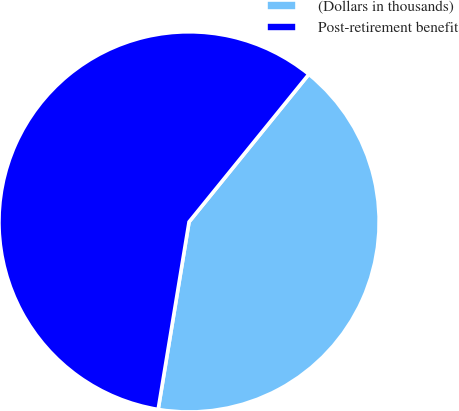<chart> <loc_0><loc_0><loc_500><loc_500><pie_chart><fcel>(Dollars in thousands)<fcel>Post-retirement benefit<nl><fcel>41.75%<fcel>58.25%<nl></chart> 